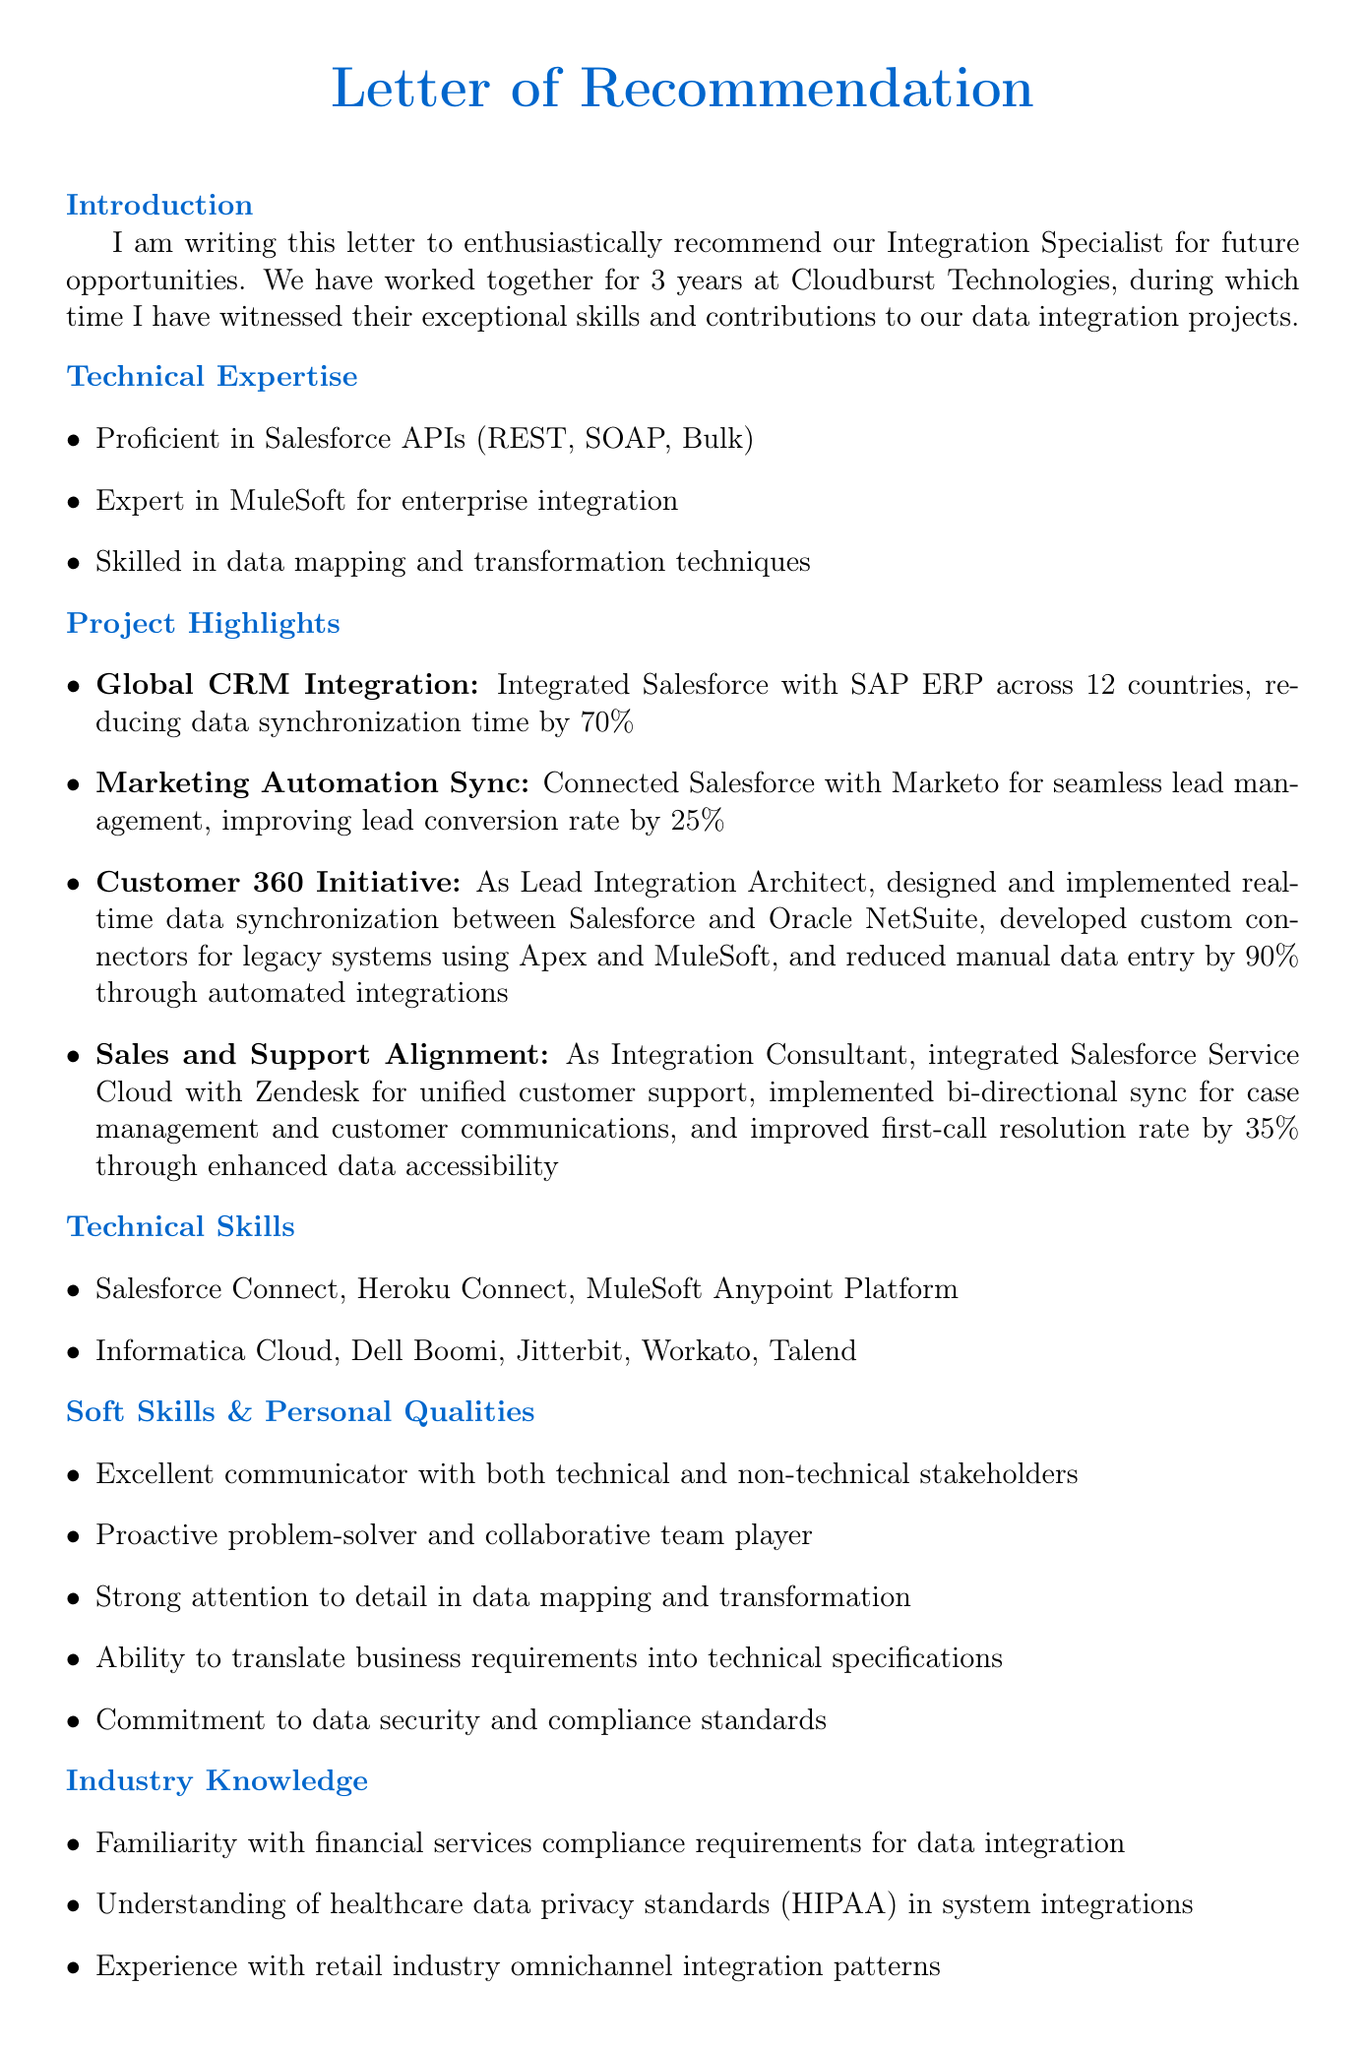what is the main purpose of the letter? The purpose is to recommend the Integration Specialist for future opportunities.
Answer: recommend Integration Specialist for future opportunities how long did the writer work with the Integration Specialist? The duration mentioned in the letter indicates they worked together for 3 years.
Answer: 3 years which project achieved a 70% reduction in data synchronization time? The project highlighted in the document that had this outcome is the Global CRM Integration.
Answer: Global CRM Integration what role did the Integration Specialist have in the Customer 360 Initiative? The letter states that they were the Lead Integration Architect for this project.
Answer: Lead Integration Architect which technical skills are mentioned in the letter? The letter lists several skills, including Salesforce Connect, Heroku Connect, and MuleSoft Anypoint Platform.
Answer: Salesforce Connect, Heroku Connect, MuleSoft Anypoint Platform what is one of the personal qualities of the Integration Specialist? The letter mentions that they have strong attention to detail in data mapping and transformation.
Answer: strong attention to detail in data mapping and transformation what outcome did the Marketing Automation Sync project achieve? The outcome listed in the letter states that it improved lead conversion rate by 25%.
Answer: improved lead conversion rate by 25% what is the summary statement in the conclusion? The summary statement emphasizes that the Integration Specialist is an invaluable asset to any integration team.
Answer: invaluable asset to any integration team how does the writer describe the Integration Specialist's communication skills? They are described as an excellent communicator with both technical and non-technical stakeholders.
Answer: excellent communicator with both technical and non-technical stakeholders 